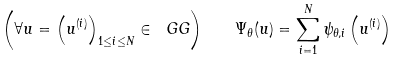Convert formula to latex. <formula><loc_0><loc_0><loc_500><loc_500>\left ( \forall u = \left ( u ^ { ( i ) } \right ) _ { 1 \leq i \leq N } \in \ G G \right ) \quad \Psi _ { \theta } ( u ) = \sum _ { i = 1 } ^ { N } \psi _ { \theta , i } \left ( u ^ { ( i ) } \right )</formula> 